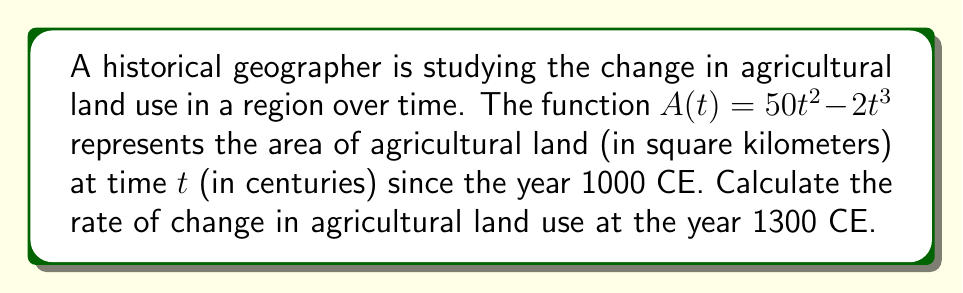Show me your answer to this math problem. 1. We need to find the derivative of $A(t)$ to determine the rate of change:
   $$\frac{dA}{dt} = \frac{d}{dt}(50t^2 - 2t^3)$$
   $$\frac{dA}{dt} = 100t - 6t^2$$

2. The year 1300 CE is 3 centuries after 1000 CE, so we need to evaluate the derivative at $t = 3$:
   $$\frac{dA}{dt}|_{t=3} = 100(3) - 6(3)^2$$
   $$\frac{dA}{dt}|_{t=3} = 300 - 6(9)$$
   $$\frac{dA}{dt}|_{t=3} = 300 - 54$$
   $$\frac{dA}{dt}|_{t=3} = 246$$

3. The units of the rate of change are square kilometers per century.
Answer: 246 km²/century 